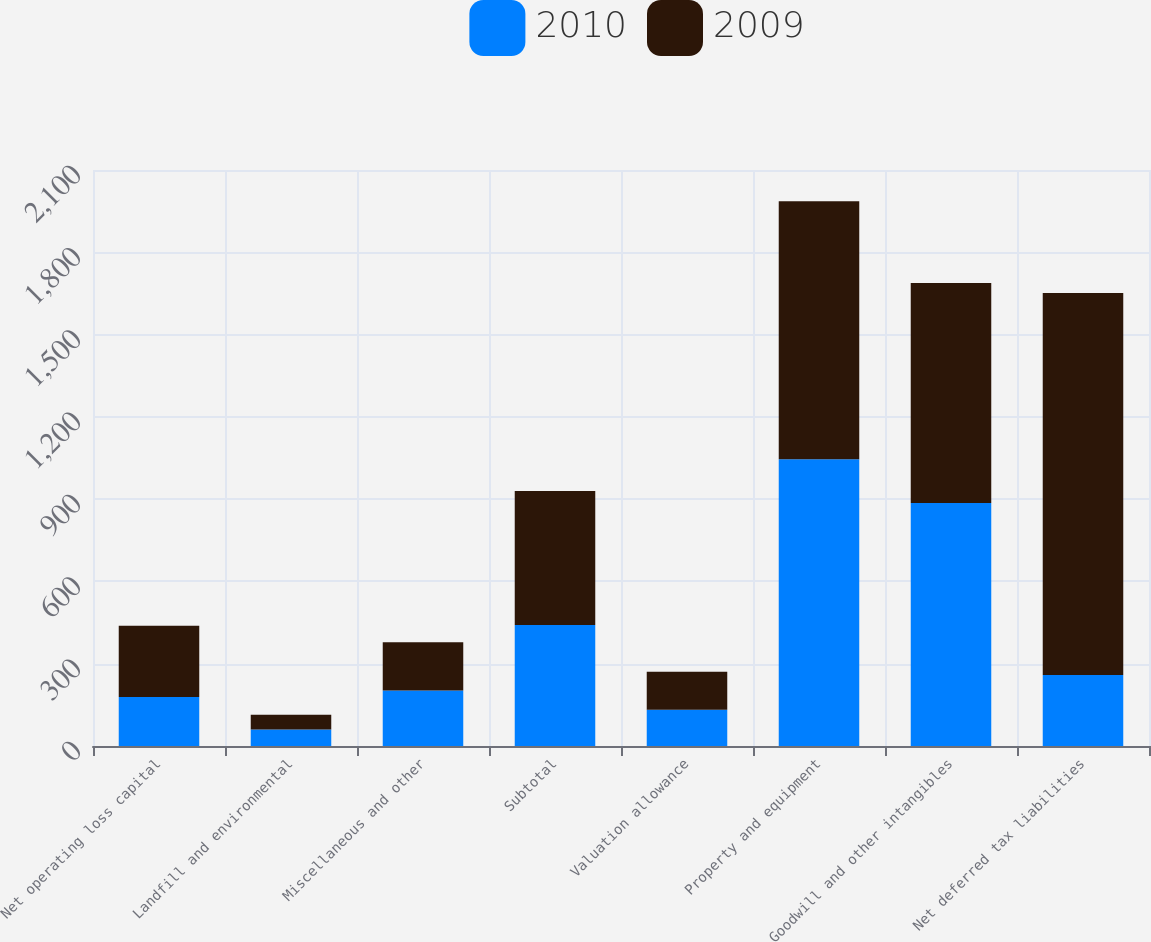<chart> <loc_0><loc_0><loc_500><loc_500><stacked_bar_chart><ecel><fcel>Net operating loss capital<fcel>Landfill and environmental<fcel>Miscellaneous and other<fcel>Subtotal<fcel>Valuation allowance<fcel>Property and equipment<fcel>Goodwill and other intangibles<fcel>Net deferred tax liabilities<nl><fcel>2010<fcel>179<fcel>60<fcel>202<fcel>441<fcel>132<fcel>1045<fcel>886<fcel>259<nl><fcel>2009<fcel>259<fcel>54<fcel>176<fcel>489<fcel>139<fcel>941<fcel>802<fcel>1393<nl></chart> 